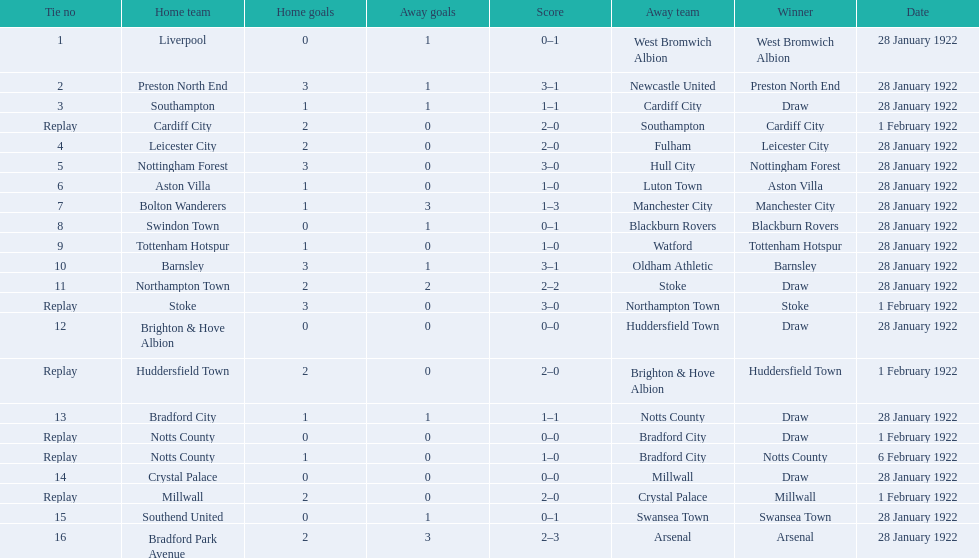What was the score in the aston villa game? 1–0. Which other team had an identical score? Tottenham Hotspur. 